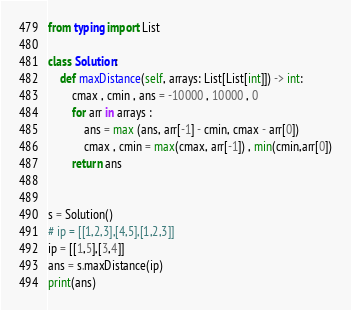Convert code to text. <code><loc_0><loc_0><loc_500><loc_500><_Python_>from typing import List

class Solution:
    def maxDistance(self, arrays: List[List[int]]) -> int:
        cmax , cmin , ans = -10000 , 10000 , 0
        for arr in arrays :
            ans = max (ans, arr[-1] - cmin, cmax - arr[0])
            cmax , cmin = max(cmax, arr[-1]) , min(cmin,arr[0])
        return ans


s = Solution()
# ip = [[1,2,3],[4,5],[1,2,3]]
ip = [[1,5],[3,4]]
ans = s.maxDistance(ip)
print(ans)</code> 